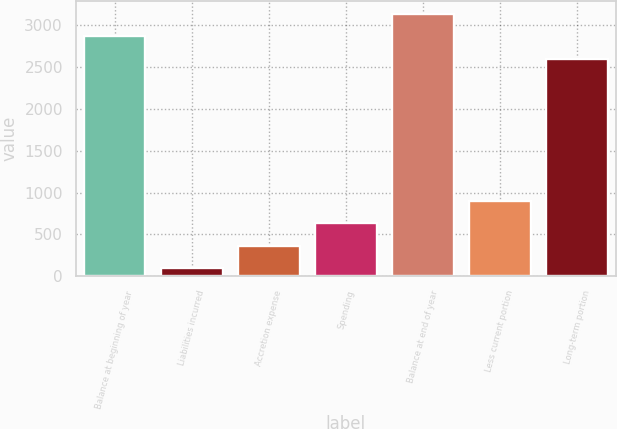Convert chart to OTSL. <chart><loc_0><loc_0><loc_500><loc_500><bar_chart><fcel>Balance at beginning of year<fcel>Liabilities incurred<fcel>Accretion expense<fcel>Spending<fcel>Balance at end of year<fcel>Less current portion<fcel>Long-term portion<nl><fcel>2866.4<fcel>97<fcel>364.4<fcel>631.8<fcel>3133.8<fcel>899.2<fcel>2599<nl></chart> 